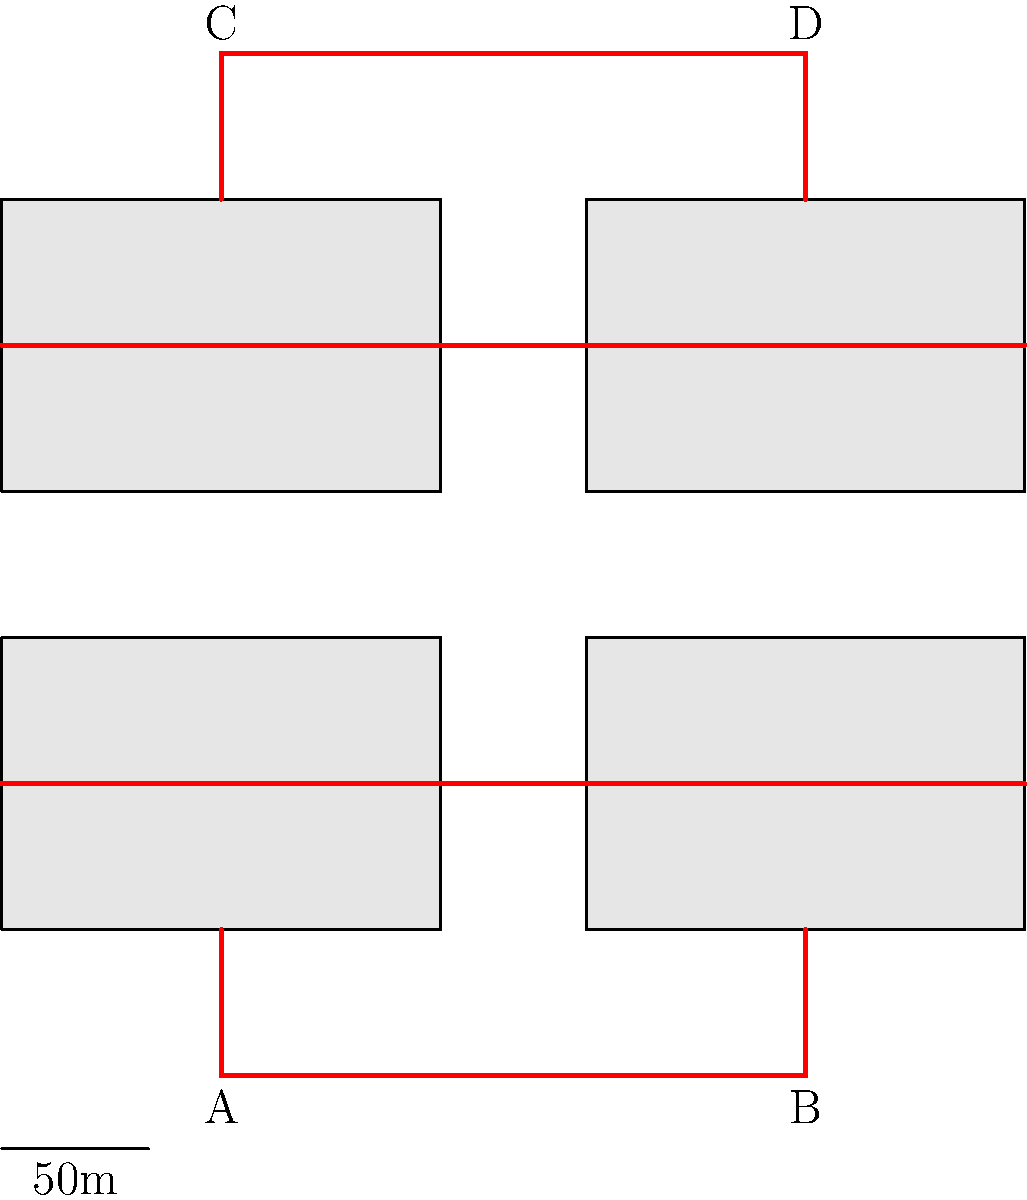As a concerned parent advocating for increased campus security, you're reviewing the emergency exit routes on the UTD campus map. The red lines represent emergency exit paths, and each square represents a 50m x 50m area. What is the minimum distance (in meters) that a student would need to travel to reach any exit point (A, B, C, or D) from the center of the campus? To solve this problem, we need to follow these steps:

1. Identify the center of the campus:
   The center is at the intersection of the two horizontal red lines in the middle of the map.

2. Calculate the distance from the center to each exit point:
   a) To point A: 1.5 squares down and 1.5 squares left
   b) To point B: 1.5 squares down and 1.5 squares right
   c) To point C: 1.5 squares up and 1.5 squares left
   d) To point D: 1.5 squares up and 1.5 squares right

3. Use the Pythagorean theorem to calculate the diagonal distance:
   Distance = $\sqrt{(1.5^2 + 1.5^2)} \times 50m$

4. Simplify the calculation:
   Distance = $\sqrt{4.5} \times 50m$
   Distance = $2.12 \times 50m$
   Distance = 106m

Therefore, the minimum distance a student would need to travel from the center of the campus to reach any exit point is approximately 106 meters.
Answer: 106 meters 